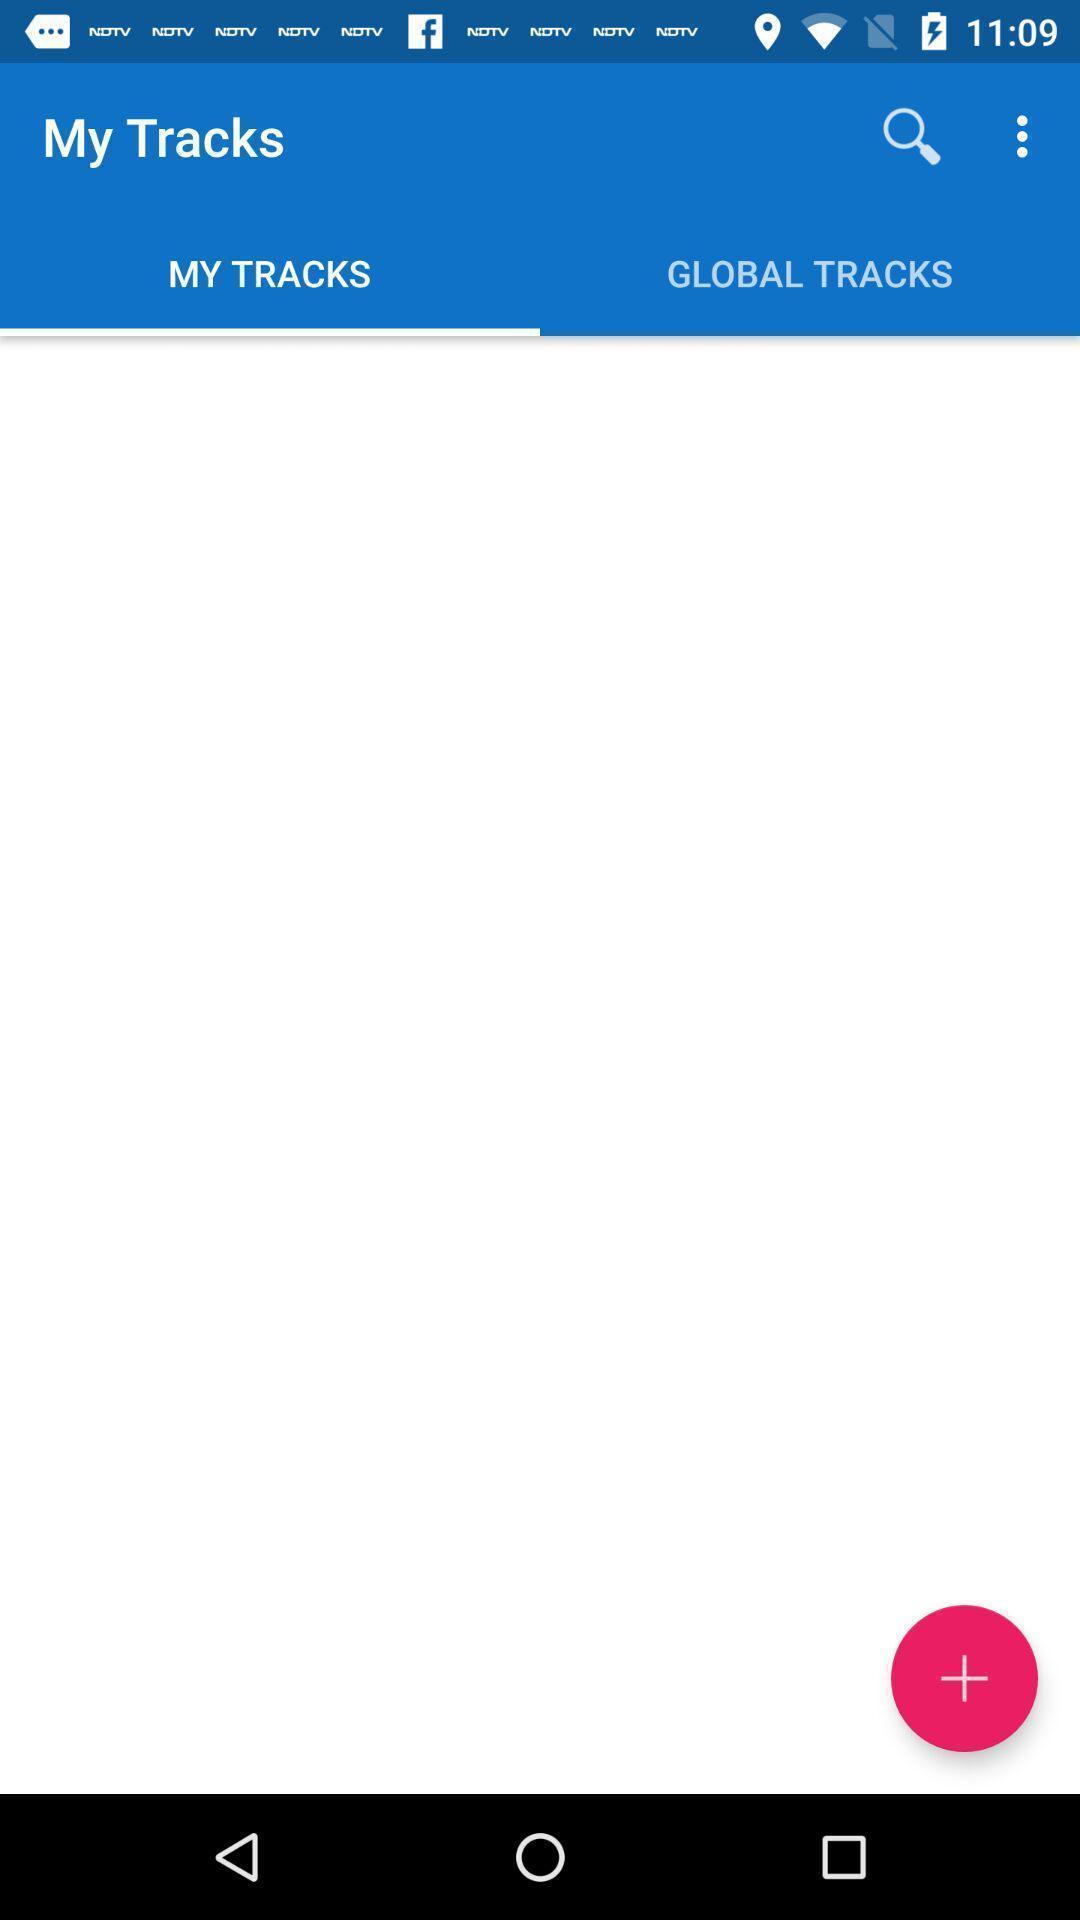Provide a textual representation of this image. Screen displaying the my tracks page. 